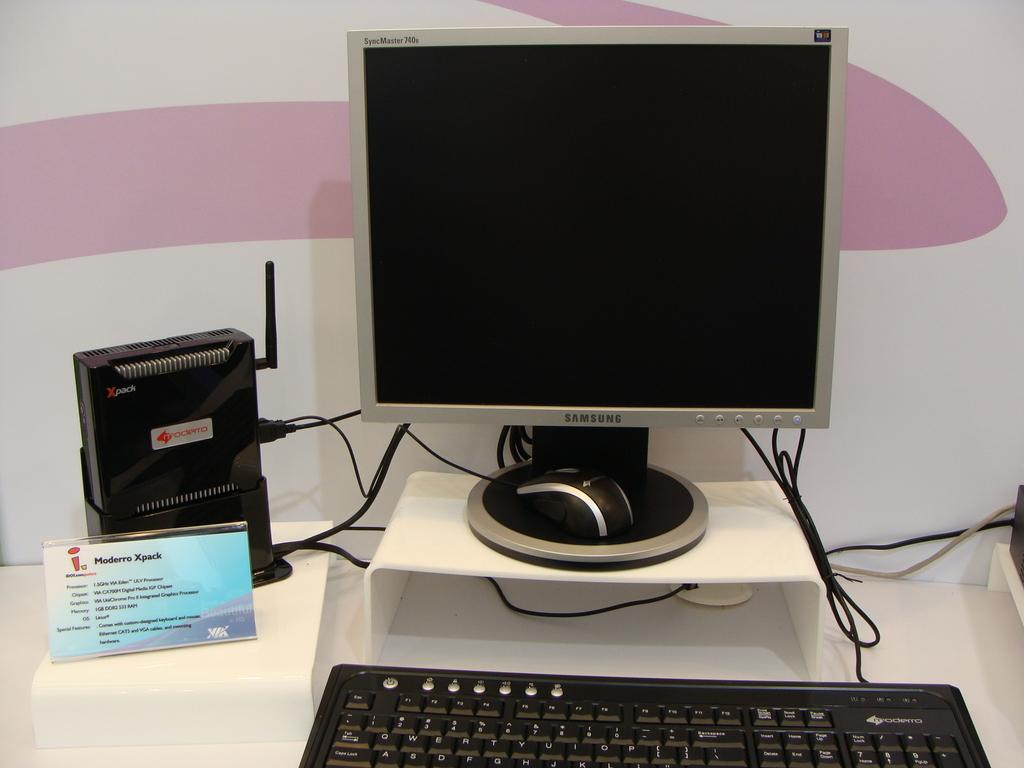What's the brand name of this monitor?
Offer a very short reply. Samsung. What type of keyboard is this?
Make the answer very short. Moderro. 